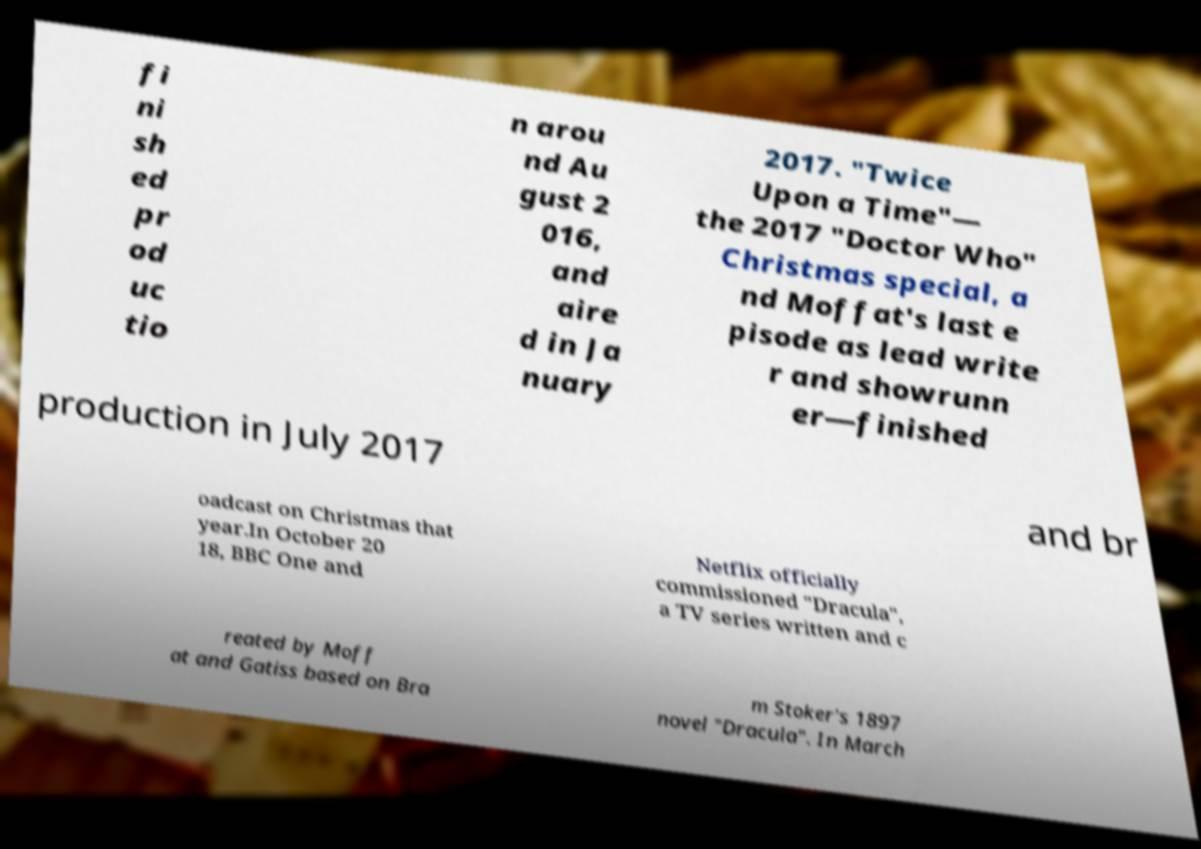Could you assist in decoding the text presented in this image and type it out clearly? fi ni sh ed pr od uc tio n arou nd Au gust 2 016, and aire d in Ja nuary 2017. "Twice Upon a Time"— the 2017 "Doctor Who" Christmas special, a nd Moffat's last e pisode as lead write r and showrunn er—finished production in July 2017 and br oadcast on Christmas that year.In October 20 18, BBC One and Netflix officially commissioned "Dracula", a TV series written and c reated by Moff at and Gatiss based on Bra m Stoker's 1897 novel "Dracula". In March 